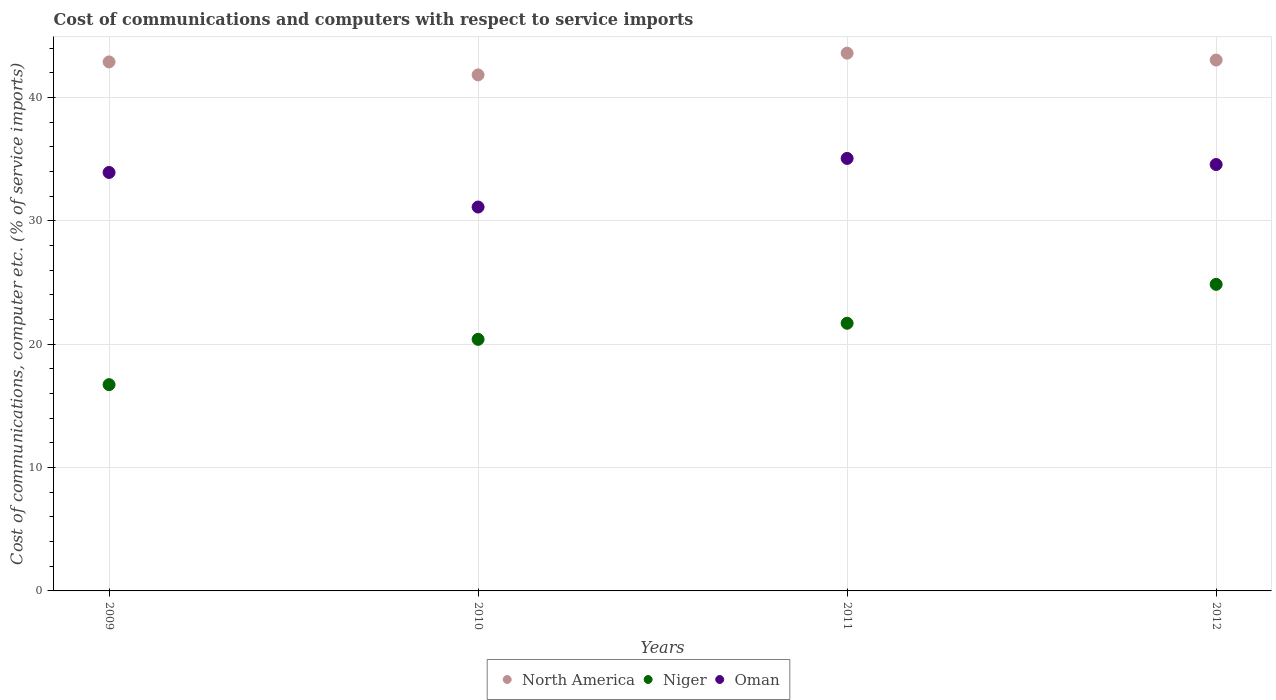How many different coloured dotlines are there?
Provide a succinct answer. 3. What is the cost of communications and computers in Niger in 2010?
Provide a succinct answer. 20.4. Across all years, what is the maximum cost of communications and computers in North America?
Your response must be concise. 43.61. Across all years, what is the minimum cost of communications and computers in Oman?
Keep it short and to the point. 31.13. In which year was the cost of communications and computers in North America maximum?
Your answer should be compact. 2011. What is the total cost of communications and computers in Oman in the graph?
Make the answer very short. 134.71. What is the difference between the cost of communications and computers in Oman in 2010 and that in 2012?
Provide a succinct answer. -3.45. What is the difference between the cost of communications and computers in North America in 2011 and the cost of communications and computers in Oman in 2010?
Offer a terse response. 12.48. What is the average cost of communications and computers in Oman per year?
Ensure brevity in your answer.  33.68. In the year 2012, what is the difference between the cost of communications and computers in Oman and cost of communications and computers in Niger?
Keep it short and to the point. 9.72. What is the ratio of the cost of communications and computers in Oman in 2011 to that in 2012?
Provide a short and direct response. 1.01. Is the cost of communications and computers in Oman in 2009 less than that in 2012?
Keep it short and to the point. Yes. What is the difference between the highest and the second highest cost of communications and computers in North America?
Give a very brief answer. 0.56. What is the difference between the highest and the lowest cost of communications and computers in Oman?
Offer a terse response. 3.94. In how many years, is the cost of communications and computers in North America greater than the average cost of communications and computers in North America taken over all years?
Provide a succinct answer. 3. Is the sum of the cost of communications and computers in Niger in 2011 and 2012 greater than the maximum cost of communications and computers in Oman across all years?
Offer a very short reply. Yes. Is it the case that in every year, the sum of the cost of communications and computers in Oman and cost of communications and computers in Niger  is greater than the cost of communications and computers in North America?
Provide a short and direct response. Yes. Is the cost of communications and computers in Oman strictly less than the cost of communications and computers in North America over the years?
Your response must be concise. Yes. How many dotlines are there?
Provide a succinct answer. 3. How many years are there in the graph?
Keep it short and to the point. 4. Are the values on the major ticks of Y-axis written in scientific E-notation?
Provide a succinct answer. No. Does the graph contain any zero values?
Keep it short and to the point. No. What is the title of the graph?
Offer a terse response. Cost of communications and computers with respect to service imports. Does "Micronesia" appear as one of the legend labels in the graph?
Make the answer very short. No. What is the label or title of the X-axis?
Your response must be concise. Years. What is the label or title of the Y-axis?
Offer a very short reply. Cost of communications, computer etc. (% of service imports). What is the Cost of communications, computer etc. (% of service imports) in North America in 2009?
Provide a succinct answer. 42.89. What is the Cost of communications, computer etc. (% of service imports) in Niger in 2009?
Ensure brevity in your answer.  16.73. What is the Cost of communications, computer etc. (% of service imports) in Oman in 2009?
Your answer should be very brief. 33.93. What is the Cost of communications, computer etc. (% of service imports) of North America in 2010?
Your answer should be very brief. 41.84. What is the Cost of communications, computer etc. (% of service imports) of Niger in 2010?
Your answer should be compact. 20.4. What is the Cost of communications, computer etc. (% of service imports) of Oman in 2010?
Provide a succinct answer. 31.13. What is the Cost of communications, computer etc. (% of service imports) in North America in 2011?
Give a very brief answer. 43.61. What is the Cost of communications, computer etc. (% of service imports) of Niger in 2011?
Your answer should be very brief. 21.7. What is the Cost of communications, computer etc. (% of service imports) of Oman in 2011?
Provide a succinct answer. 35.07. What is the Cost of communications, computer etc. (% of service imports) in North America in 2012?
Your response must be concise. 43.05. What is the Cost of communications, computer etc. (% of service imports) of Niger in 2012?
Your answer should be very brief. 24.86. What is the Cost of communications, computer etc. (% of service imports) in Oman in 2012?
Keep it short and to the point. 34.57. Across all years, what is the maximum Cost of communications, computer etc. (% of service imports) of North America?
Offer a very short reply. 43.61. Across all years, what is the maximum Cost of communications, computer etc. (% of service imports) in Niger?
Keep it short and to the point. 24.86. Across all years, what is the maximum Cost of communications, computer etc. (% of service imports) of Oman?
Offer a very short reply. 35.07. Across all years, what is the minimum Cost of communications, computer etc. (% of service imports) of North America?
Your answer should be compact. 41.84. Across all years, what is the minimum Cost of communications, computer etc. (% of service imports) of Niger?
Provide a short and direct response. 16.73. Across all years, what is the minimum Cost of communications, computer etc. (% of service imports) of Oman?
Offer a terse response. 31.13. What is the total Cost of communications, computer etc. (% of service imports) in North America in the graph?
Your answer should be very brief. 171.39. What is the total Cost of communications, computer etc. (% of service imports) of Niger in the graph?
Provide a succinct answer. 83.69. What is the total Cost of communications, computer etc. (% of service imports) in Oman in the graph?
Ensure brevity in your answer.  134.71. What is the difference between the Cost of communications, computer etc. (% of service imports) in North America in 2009 and that in 2010?
Ensure brevity in your answer.  1.05. What is the difference between the Cost of communications, computer etc. (% of service imports) in Niger in 2009 and that in 2010?
Offer a terse response. -3.67. What is the difference between the Cost of communications, computer etc. (% of service imports) in Oman in 2009 and that in 2010?
Offer a terse response. 2.8. What is the difference between the Cost of communications, computer etc. (% of service imports) of North America in 2009 and that in 2011?
Offer a very short reply. -0.71. What is the difference between the Cost of communications, computer etc. (% of service imports) in Niger in 2009 and that in 2011?
Your response must be concise. -4.98. What is the difference between the Cost of communications, computer etc. (% of service imports) of Oman in 2009 and that in 2011?
Provide a short and direct response. -1.14. What is the difference between the Cost of communications, computer etc. (% of service imports) in North America in 2009 and that in 2012?
Offer a terse response. -0.15. What is the difference between the Cost of communications, computer etc. (% of service imports) in Niger in 2009 and that in 2012?
Provide a short and direct response. -8.13. What is the difference between the Cost of communications, computer etc. (% of service imports) of Oman in 2009 and that in 2012?
Provide a succinct answer. -0.64. What is the difference between the Cost of communications, computer etc. (% of service imports) in North America in 2010 and that in 2011?
Make the answer very short. -1.76. What is the difference between the Cost of communications, computer etc. (% of service imports) of Niger in 2010 and that in 2011?
Provide a short and direct response. -1.3. What is the difference between the Cost of communications, computer etc. (% of service imports) in Oman in 2010 and that in 2011?
Give a very brief answer. -3.94. What is the difference between the Cost of communications, computer etc. (% of service imports) of North America in 2010 and that in 2012?
Give a very brief answer. -1.2. What is the difference between the Cost of communications, computer etc. (% of service imports) of Niger in 2010 and that in 2012?
Ensure brevity in your answer.  -4.46. What is the difference between the Cost of communications, computer etc. (% of service imports) of Oman in 2010 and that in 2012?
Your answer should be very brief. -3.45. What is the difference between the Cost of communications, computer etc. (% of service imports) of North America in 2011 and that in 2012?
Provide a succinct answer. 0.56. What is the difference between the Cost of communications, computer etc. (% of service imports) in Niger in 2011 and that in 2012?
Keep it short and to the point. -3.16. What is the difference between the Cost of communications, computer etc. (% of service imports) in Oman in 2011 and that in 2012?
Provide a short and direct response. 0.5. What is the difference between the Cost of communications, computer etc. (% of service imports) of North America in 2009 and the Cost of communications, computer etc. (% of service imports) of Niger in 2010?
Your response must be concise. 22.49. What is the difference between the Cost of communications, computer etc. (% of service imports) of North America in 2009 and the Cost of communications, computer etc. (% of service imports) of Oman in 2010?
Provide a short and direct response. 11.77. What is the difference between the Cost of communications, computer etc. (% of service imports) of Niger in 2009 and the Cost of communications, computer etc. (% of service imports) of Oman in 2010?
Provide a short and direct response. -14.4. What is the difference between the Cost of communications, computer etc. (% of service imports) in North America in 2009 and the Cost of communications, computer etc. (% of service imports) in Niger in 2011?
Ensure brevity in your answer.  21.19. What is the difference between the Cost of communications, computer etc. (% of service imports) in North America in 2009 and the Cost of communications, computer etc. (% of service imports) in Oman in 2011?
Offer a very short reply. 7.82. What is the difference between the Cost of communications, computer etc. (% of service imports) of Niger in 2009 and the Cost of communications, computer etc. (% of service imports) of Oman in 2011?
Give a very brief answer. -18.34. What is the difference between the Cost of communications, computer etc. (% of service imports) in North America in 2009 and the Cost of communications, computer etc. (% of service imports) in Niger in 2012?
Offer a terse response. 18.04. What is the difference between the Cost of communications, computer etc. (% of service imports) of North America in 2009 and the Cost of communications, computer etc. (% of service imports) of Oman in 2012?
Offer a very short reply. 8.32. What is the difference between the Cost of communications, computer etc. (% of service imports) in Niger in 2009 and the Cost of communications, computer etc. (% of service imports) in Oman in 2012?
Offer a very short reply. -17.85. What is the difference between the Cost of communications, computer etc. (% of service imports) in North America in 2010 and the Cost of communications, computer etc. (% of service imports) in Niger in 2011?
Your response must be concise. 20.14. What is the difference between the Cost of communications, computer etc. (% of service imports) of North America in 2010 and the Cost of communications, computer etc. (% of service imports) of Oman in 2011?
Offer a very short reply. 6.77. What is the difference between the Cost of communications, computer etc. (% of service imports) of Niger in 2010 and the Cost of communications, computer etc. (% of service imports) of Oman in 2011?
Your answer should be compact. -14.67. What is the difference between the Cost of communications, computer etc. (% of service imports) of North America in 2010 and the Cost of communications, computer etc. (% of service imports) of Niger in 2012?
Provide a succinct answer. 16.98. What is the difference between the Cost of communications, computer etc. (% of service imports) in North America in 2010 and the Cost of communications, computer etc. (% of service imports) in Oman in 2012?
Make the answer very short. 7.27. What is the difference between the Cost of communications, computer etc. (% of service imports) of Niger in 2010 and the Cost of communications, computer etc. (% of service imports) of Oman in 2012?
Your answer should be very brief. -14.18. What is the difference between the Cost of communications, computer etc. (% of service imports) in North America in 2011 and the Cost of communications, computer etc. (% of service imports) in Niger in 2012?
Provide a short and direct response. 18.75. What is the difference between the Cost of communications, computer etc. (% of service imports) in North America in 2011 and the Cost of communications, computer etc. (% of service imports) in Oman in 2012?
Provide a short and direct response. 9.03. What is the difference between the Cost of communications, computer etc. (% of service imports) of Niger in 2011 and the Cost of communications, computer etc. (% of service imports) of Oman in 2012?
Your response must be concise. -12.87. What is the average Cost of communications, computer etc. (% of service imports) of North America per year?
Offer a very short reply. 42.85. What is the average Cost of communications, computer etc. (% of service imports) in Niger per year?
Make the answer very short. 20.92. What is the average Cost of communications, computer etc. (% of service imports) of Oman per year?
Keep it short and to the point. 33.68. In the year 2009, what is the difference between the Cost of communications, computer etc. (% of service imports) in North America and Cost of communications, computer etc. (% of service imports) in Niger?
Offer a terse response. 26.17. In the year 2009, what is the difference between the Cost of communications, computer etc. (% of service imports) of North America and Cost of communications, computer etc. (% of service imports) of Oman?
Keep it short and to the point. 8.96. In the year 2009, what is the difference between the Cost of communications, computer etc. (% of service imports) of Niger and Cost of communications, computer etc. (% of service imports) of Oman?
Ensure brevity in your answer.  -17.2. In the year 2010, what is the difference between the Cost of communications, computer etc. (% of service imports) of North America and Cost of communications, computer etc. (% of service imports) of Niger?
Keep it short and to the point. 21.44. In the year 2010, what is the difference between the Cost of communications, computer etc. (% of service imports) of North America and Cost of communications, computer etc. (% of service imports) of Oman?
Keep it short and to the point. 10.71. In the year 2010, what is the difference between the Cost of communications, computer etc. (% of service imports) of Niger and Cost of communications, computer etc. (% of service imports) of Oman?
Offer a very short reply. -10.73. In the year 2011, what is the difference between the Cost of communications, computer etc. (% of service imports) of North America and Cost of communications, computer etc. (% of service imports) of Niger?
Your answer should be compact. 21.9. In the year 2011, what is the difference between the Cost of communications, computer etc. (% of service imports) in North America and Cost of communications, computer etc. (% of service imports) in Oman?
Offer a very short reply. 8.54. In the year 2011, what is the difference between the Cost of communications, computer etc. (% of service imports) of Niger and Cost of communications, computer etc. (% of service imports) of Oman?
Make the answer very short. -13.37. In the year 2012, what is the difference between the Cost of communications, computer etc. (% of service imports) in North America and Cost of communications, computer etc. (% of service imports) in Niger?
Provide a succinct answer. 18.19. In the year 2012, what is the difference between the Cost of communications, computer etc. (% of service imports) in North America and Cost of communications, computer etc. (% of service imports) in Oman?
Offer a terse response. 8.47. In the year 2012, what is the difference between the Cost of communications, computer etc. (% of service imports) of Niger and Cost of communications, computer etc. (% of service imports) of Oman?
Make the answer very short. -9.72. What is the ratio of the Cost of communications, computer etc. (% of service imports) of North America in 2009 to that in 2010?
Offer a very short reply. 1.03. What is the ratio of the Cost of communications, computer etc. (% of service imports) in Niger in 2009 to that in 2010?
Give a very brief answer. 0.82. What is the ratio of the Cost of communications, computer etc. (% of service imports) of Oman in 2009 to that in 2010?
Provide a short and direct response. 1.09. What is the ratio of the Cost of communications, computer etc. (% of service imports) of North America in 2009 to that in 2011?
Offer a very short reply. 0.98. What is the ratio of the Cost of communications, computer etc. (% of service imports) in Niger in 2009 to that in 2011?
Your answer should be very brief. 0.77. What is the ratio of the Cost of communications, computer etc. (% of service imports) of Oman in 2009 to that in 2011?
Your answer should be compact. 0.97. What is the ratio of the Cost of communications, computer etc. (% of service imports) in Niger in 2009 to that in 2012?
Make the answer very short. 0.67. What is the ratio of the Cost of communications, computer etc. (% of service imports) in Oman in 2009 to that in 2012?
Keep it short and to the point. 0.98. What is the ratio of the Cost of communications, computer etc. (% of service imports) of North America in 2010 to that in 2011?
Give a very brief answer. 0.96. What is the ratio of the Cost of communications, computer etc. (% of service imports) of Niger in 2010 to that in 2011?
Ensure brevity in your answer.  0.94. What is the ratio of the Cost of communications, computer etc. (% of service imports) of Oman in 2010 to that in 2011?
Your answer should be very brief. 0.89. What is the ratio of the Cost of communications, computer etc. (% of service imports) of North America in 2010 to that in 2012?
Keep it short and to the point. 0.97. What is the ratio of the Cost of communications, computer etc. (% of service imports) in Niger in 2010 to that in 2012?
Offer a very short reply. 0.82. What is the ratio of the Cost of communications, computer etc. (% of service imports) in Oman in 2010 to that in 2012?
Provide a succinct answer. 0.9. What is the ratio of the Cost of communications, computer etc. (% of service imports) of North America in 2011 to that in 2012?
Offer a terse response. 1.01. What is the ratio of the Cost of communications, computer etc. (% of service imports) of Niger in 2011 to that in 2012?
Your response must be concise. 0.87. What is the ratio of the Cost of communications, computer etc. (% of service imports) of Oman in 2011 to that in 2012?
Offer a very short reply. 1.01. What is the difference between the highest and the second highest Cost of communications, computer etc. (% of service imports) in North America?
Your answer should be very brief. 0.56. What is the difference between the highest and the second highest Cost of communications, computer etc. (% of service imports) in Niger?
Give a very brief answer. 3.16. What is the difference between the highest and the second highest Cost of communications, computer etc. (% of service imports) of Oman?
Ensure brevity in your answer.  0.5. What is the difference between the highest and the lowest Cost of communications, computer etc. (% of service imports) in North America?
Offer a terse response. 1.76. What is the difference between the highest and the lowest Cost of communications, computer etc. (% of service imports) in Niger?
Provide a short and direct response. 8.13. What is the difference between the highest and the lowest Cost of communications, computer etc. (% of service imports) of Oman?
Offer a very short reply. 3.94. 